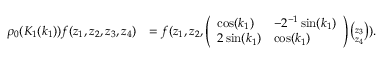Convert formula to latex. <formula><loc_0><loc_0><loc_500><loc_500>\begin{array} { r l } { \rho _ { 0 } ( K _ { 1 } ( k _ { 1 } ) ) f ( z _ { 1 } , z _ { 2 } , z _ { 3 } , z _ { 4 } ) } & { = f ( z _ { 1 } , z _ { 2 } , \left ( \begin{array} { l l } { \cos ( k _ { 1 } ) } & { - 2 ^ { - 1 } \sin ( k _ { 1 } ) } \\ { 2 \sin ( k _ { 1 } ) } & { \cos ( k _ { 1 } ) } \end{array} \right ) \binom { z _ { 3 } } { z _ { 4 } } ) . } \end{array}</formula> 